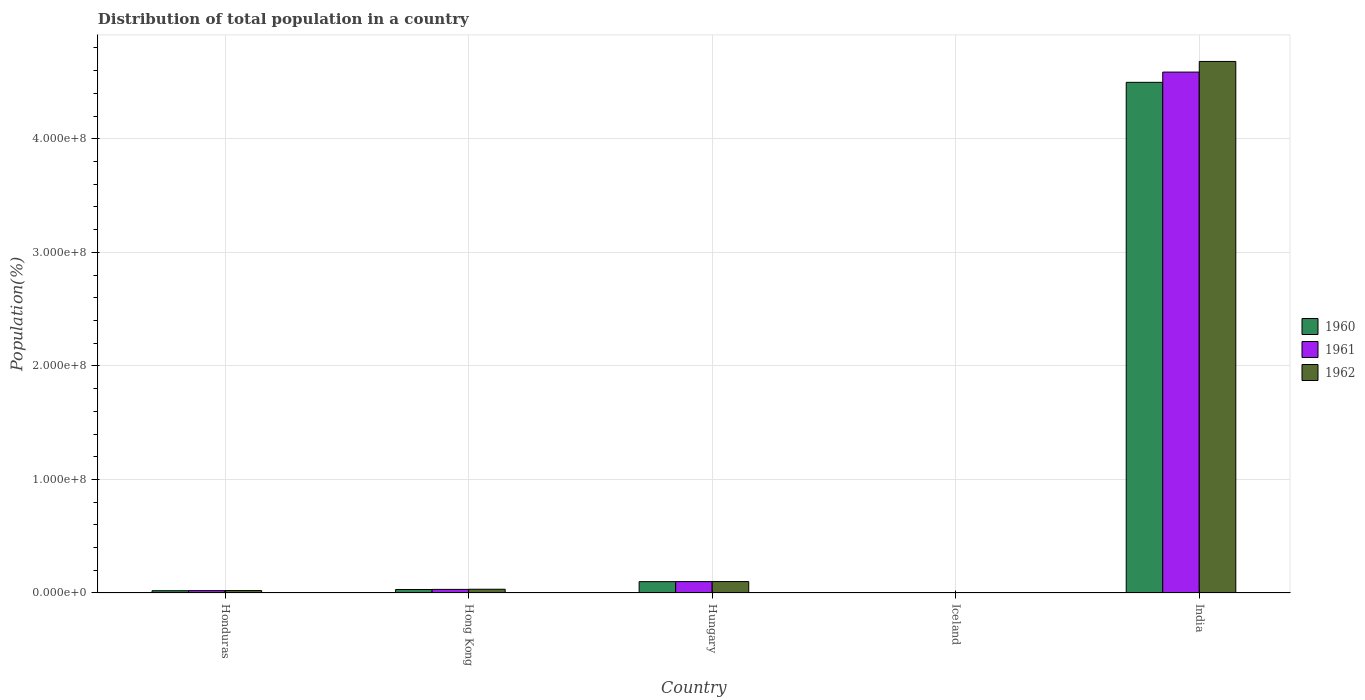How many different coloured bars are there?
Your answer should be very brief. 3. How many groups of bars are there?
Your answer should be very brief. 5. How many bars are there on the 4th tick from the left?
Your response must be concise. 3. How many bars are there on the 5th tick from the right?
Your answer should be compact. 3. What is the label of the 1st group of bars from the left?
Make the answer very short. Honduras. In how many cases, is the number of bars for a given country not equal to the number of legend labels?
Your answer should be compact. 0. What is the population of in 1962 in Honduras?
Your answer should be compact. 2.14e+06. Across all countries, what is the maximum population of in 1961?
Your response must be concise. 4.59e+08. Across all countries, what is the minimum population of in 1960?
Your answer should be very brief. 1.76e+05. In which country was the population of in 1960 maximum?
Give a very brief answer. India. In which country was the population of in 1961 minimum?
Offer a very short reply. Iceland. What is the total population of in 1961 in the graph?
Make the answer very short. 4.74e+08. What is the difference between the population of in 1961 in Hungary and that in India?
Provide a short and direct response. -4.49e+08. What is the difference between the population of in 1962 in Honduras and the population of in 1960 in Hungary?
Your response must be concise. -7.84e+06. What is the average population of in 1960 per country?
Keep it short and to the point. 9.30e+07. What is the difference between the population of of/in 1961 and population of of/in 1960 in Hungary?
Ensure brevity in your answer.  4.54e+04. In how many countries, is the population of in 1961 greater than 220000000 %?
Offer a very short reply. 1. What is the ratio of the population of in 1962 in Hungary to that in India?
Keep it short and to the point. 0.02. What is the difference between the highest and the second highest population of in 1961?
Provide a short and direct response. 4.56e+08. What is the difference between the highest and the lowest population of in 1960?
Offer a very short reply. 4.49e+08. In how many countries, is the population of in 1962 greater than the average population of in 1962 taken over all countries?
Keep it short and to the point. 1. What does the 3rd bar from the right in Hungary represents?
Provide a short and direct response. 1960. How many bars are there?
Keep it short and to the point. 15. Are all the bars in the graph horizontal?
Provide a succinct answer. No. Are the values on the major ticks of Y-axis written in scientific E-notation?
Offer a terse response. Yes. Does the graph contain any zero values?
Your response must be concise. No. Where does the legend appear in the graph?
Your answer should be very brief. Center right. How many legend labels are there?
Ensure brevity in your answer.  3. How are the legend labels stacked?
Provide a succinct answer. Vertical. What is the title of the graph?
Offer a terse response. Distribution of total population in a country. What is the label or title of the Y-axis?
Give a very brief answer. Population(%). What is the Population(%) in 1960 in Honduras?
Your answer should be compact. 2.00e+06. What is the Population(%) in 1961 in Honduras?
Give a very brief answer. 2.07e+06. What is the Population(%) of 1962 in Honduras?
Your answer should be very brief. 2.14e+06. What is the Population(%) in 1960 in Hong Kong?
Offer a very short reply. 3.08e+06. What is the Population(%) of 1961 in Hong Kong?
Your answer should be very brief. 3.17e+06. What is the Population(%) in 1962 in Hong Kong?
Your answer should be very brief. 3.31e+06. What is the Population(%) in 1960 in Hungary?
Offer a very short reply. 9.98e+06. What is the Population(%) in 1961 in Hungary?
Your answer should be compact. 1.00e+07. What is the Population(%) in 1962 in Hungary?
Offer a very short reply. 1.01e+07. What is the Population(%) of 1960 in Iceland?
Give a very brief answer. 1.76e+05. What is the Population(%) in 1961 in Iceland?
Offer a very short reply. 1.79e+05. What is the Population(%) in 1962 in Iceland?
Offer a very short reply. 1.82e+05. What is the Population(%) of 1960 in India?
Keep it short and to the point. 4.50e+08. What is the Population(%) in 1961 in India?
Offer a very short reply. 4.59e+08. What is the Population(%) in 1962 in India?
Offer a very short reply. 4.68e+08. Across all countries, what is the maximum Population(%) in 1960?
Provide a succinct answer. 4.50e+08. Across all countries, what is the maximum Population(%) in 1961?
Keep it short and to the point. 4.59e+08. Across all countries, what is the maximum Population(%) of 1962?
Your answer should be very brief. 4.68e+08. Across all countries, what is the minimum Population(%) of 1960?
Provide a succinct answer. 1.76e+05. Across all countries, what is the minimum Population(%) of 1961?
Ensure brevity in your answer.  1.79e+05. Across all countries, what is the minimum Population(%) of 1962?
Keep it short and to the point. 1.82e+05. What is the total Population(%) of 1960 in the graph?
Make the answer very short. 4.65e+08. What is the total Population(%) in 1961 in the graph?
Offer a terse response. 4.74e+08. What is the total Population(%) in 1962 in the graph?
Your answer should be compact. 4.84e+08. What is the difference between the Population(%) of 1960 in Honduras and that in Hong Kong?
Provide a short and direct response. -1.07e+06. What is the difference between the Population(%) of 1961 in Honduras and that in Hong Kong?
Ensure brevity in your answer.  -1.10e+06. What is the difference between the Population(%) in 1962 in Honduras and that in Hong Kong?
Your answer should be compact. -1.17e+06. What is the difference between the Population(%) of 1960 in Honduras and that in Hungary?
Make the answer very short. -7.98e+06. What is the difference between the Population(%) of 1961 in Honduras and that in Hungary?
Offer a very short reply. -7.96e+06. What is the difference between the Population(%) in 1962 in Honduras and that in Hungary?
Keep it short and to the point. -7.92e+06. What is the difference between the Population(%) in 1960 in Honduras and that in Iceland?
Make the answer very short. 1.83e+06. What is the difference between the Population(%) in 1961 in Honduras and that in Iceland?
Offer a very short reply. 1.89e+06. What is the difference between the Population(%) of 1962 in Honduras and that in Iceland?
Your answer should be compact. 1.96e+06. What is the difference between the Population(%) in 1960 in Honduras and that in India?
Keep it short and to the point. -4.48e+08. What is the difference between the Population(%) in 1961 in Honduras and that in India?
Provide a succinct answer. -4.57e+08. What is the difference between the Population(%) in 1962 in Honduras and that in India?
Give a very brief answer. -4.66e+08. What is the difference between the Population(%) of 1960 in Hong Kong and that in Hungary?
Ensure brevity in your answer.  -6.91e+06. What is the difference between the Population(%) of 1961 in Hong Kong and that in Hungary?
Your answer should be very brief. -6.86e+06. What is the difference between the Population(%) of 1962 in Hong Kong and that in Hungary?
Make the answer very short. -6.76e+06. What is the difference between the Population(%) in 1960 in Hong Kong and that in Iceland?
Offer a very short reply. 2.90e+06. What is the difference between the Population(%) of 1961 in Hong Kong and that in Iceland?
Give a very brief answer. 2.99e+06. What is the difference between the Population(%) of 1962 in Hong Kong and that in Iceland?
Offer a very short reply. 3.12e+06. What is the difference between the Population(%) in 1960 in Hong Kong and that in India?
Make the answer very short. -4.47e+08. What is the difference between the Population(%) of 1961 in Hong Kong and that in India?
Your response must be concise. -4.56e+08. What is the difference between the Population(%) in 1962 in Hong Kong and that in India?
Provide a short and direct response. -4.65e+08. What is the difference between the Population(%) of 1960 in Hungary and that in Iceland?
Offer a terse response. 9.81e+06. What is the difference between the Population(%) of 1961 in Hungary and that in Iceland?
Offer a terse response. 9.85e+06. What is the difference between the Population(%) in 1962 in Hungary and that in Iceland?
Provide a succinct answer. 9.88e+06. What is the difference between the Population(%) of 1960 in Hungary and that in India?
Your response must be concise. -4.40e+08. What is the difference between the Population(%) of 1961 in Hungary and that in India?
Your answer should be very brief. -4.49e+08. What is the difference between the Population(%) in 1962 in Hungary and that in India?
Provide a succinct answer. -4.58e+08. What is the difference between the Population(%) in 1960 in Iceland and that in India?
Provide a succinct answer. -4.49e+08. What is the difference between the Population(%) of 1961 in Iceland and that in India?
Your response must be concise. -4.59e+08. What is the difference between the Population(%) in 1962 in Iceland and that in India?
Keep it short and to the point. -4.68e+08. What is the difference between the Population(%) in 1960 in Honduras and the Population(%) in 1961 in Hong Kong?
Your answer should be compact. -1.17e+06. What is the difference between the Population(%) of 1960 in Honduras and the Population(%) of 1962 in Hong Kong?
Your answer should be very brief. -1.30e+06. What is the difference between the Population(%) in 1961 in Honduras and the Population(%) in 1962 in Hong Kong?
Offer a terse response. -1.24e+06. What is the difference between the Population(%) in 1960 in Honduras and the Population(%) in 1961 in Hungary?
Offer a very short reply. -8.03e+06. What is the difference between the Population(%) of 1960 in Honduras and the Population(%) of 1962 in Hungary?
Give a very brief answer. -8.06e+06. What is the difference between the Population(%) of 1961 in Honduras and the Population(%) of 1962 in Hungary?
Your answer should be compact. -7.99e+06. What is the difference between the Population(%) of 1960 in Honduras and the Population(%) of 1961 in Iceland?
Your answer should be compact. 1.82e+06. What is the difference between the Population(%) in 1960 in Honduras and the Population(%) in 1962 in Iceland?
Provide a succinct answer. 1.82e+06. What is the difference between the Population(%) of 1961 in Honduras and the Population(%) of 1962 in Iceland?
Provide a short and direct response. 1.89e+06. What is the difference between the Population(%) of 1960 in Honduras and the Population(%) of 1961 in India?
Provide a short and direct response. -4.57e+08. What is the difference between the Population(%) in 1960 in Honduras and the Population(%) in 1962 in India?
Your answer should be very brief. -4.66e+08. What is the difference between the Population(%) in 1961 in Honduras and the Population(%) in 1962 in India?
Offer a terse response. -4.66e+08. What is the difference between the Population(%) of 1960 in Hong Kong and the Population(%) of 1961 in Hungary?
Your response must be concise. -6.95e+06. What is the difference between the Population(%) in 1960 in Hong Kong and the Population(%) in 1962 in Hungary?
Your answer should be very brief. -6.99e+06. What is the difference between the Population(%) in 1961 in Hong Kong and the Population(%) in 1962 in Hungary?
Give a very brief answer. -6.89e+06. What is the difference between the Population(%) in 1960 in Hong Kong and the Population(%) in 1961 in Iceland?
Provide a succinct answer. 2.90e+06. What is the difference between the Population(%) of 1960 in Hong Kong and the Population(%) of 1962 in Iceland?
Your response must be concise. 2.89e+06. What is the difference between the Population(%) in 1961 in Hong Kong and the Population(%) in 1962 in Iceland?
Ensure brevity in your answer.  2.99e+06. What is the difference between the Population(%) in 1960 in Hong Kong and the Population(%) in 1961 in India?
Keep it short and to the point. -4.56e+08. What is the difference between the Population(%) in 1960 in Hong Kong and the Population(%) in 1962 in India?
Offer a very short reply. -4.65e+08. What is the difference between the Population(%) of 1961 in Hong Kong and the Population(%) of 1962 in India?
Keep it short and to the point. -4.65e+08. What is the difference between the Population(%) in 1960 in Hungary and the Population(%) in 1961 in Iceland?
Give a very brief answer. 9.80e+06. What is the difference between the Population(%) in 1960 in Hungary and the Population(%) in 1962 in Iceland?
Provide a succinct answer. 9.80e+06. What is the difference between the Population(%) in 1961 in Hungary and the Population(%) in 1962 in Iceland?
Provide a succinct answer. 9.85e+06. What is the difference between the Population(%) of 1960 in Hungary and the Population(%) of 1961 in India?
Offer a terse response. -4.49e+08. What is the difference between the Population(%) of 1960 in Hungary and the Population(%) of 1962 in India?
Offer a very short reply. -4.58e+08. What is the difference between the Population(%) in 1961 in Hungary and the Population(%) in 1962 in India?
Offer a terse response. -4.58e+08. What is the difference between the Population(%) of 1960 in Iceland and the Population(%) of 1961 in India?
Your response must be concise. -4.59e+08. What is the difference between the Population(%) in 1960 in Iceland and the Population(%) in 1962 in India?
Provide a short and direct response. -4.68e+08. What is the difference between the Population(%) of 1961 in Iceland and the Population(%) of 1962 in India?
Your answer should be compact. -4.68e+08. What is the average Population(%) of 1960 per country?
Keep it short and to the point. 9.30e+07. What is the average Population(%) of 1961 per country?
Your response must be concise. 9.48e+07. What is the average Population(%) of 1962 per country?
Offer a terse response. 9.67e+07. What is the difference between the Population(%) of 1960 and Population(%) of 1961 in Honduras?
Your response must be concise. -6.68e+04. What is the difference between the Population(%) of 1960 and Population(%) of 1962 in Honduras?
Offer a terse response. -1.37e+05. What is the difference between the Population(%) in 1961 and Population(%) in 1962 in Honduras?
Provide a succinct answer. -7.01e+04. What is the difference between the Population(%) in 1960 and Population(%) in 1961 in Hong Kong?
Provide a short and direct response. -9.25e+04. What is the difference between the Population(%) of 1960 and Population(%) of 1962 in Hong Kong?
Keep it short and to the point. -2.30e+05. What is the difference between the Population(%) in 1961 and Population(%) in 1962 in Hong Kong?
Make the answer very short. -1.37e+05. What is the difference between the Population(%) of 1960 and Population(%) of 1961 in Hungary?
Your answer should be very brief. -4.54e+04. What is the difference between the Population(%) in 1960 and Population(%) in 1962 in Hungary?
Offer a very short reply. -7.78e+04. What is the difference between the Population(%) of 1961 and Population(%) of 1962 in Hungary?
Provide a short and direct response. -3.24e+04. What is the difference between the Population(%) in 1960 and Population(%) in 1961 in Iceland?
Offer a very short reply. -3455. What is the difference between the Population(%) in 1960 and Population(%) in 1962 in Iceland?
Your answer should be very brief. -6804. What is the difference between the Population(%) of 1961 and Population(%) of 1962 in Iceland?
Give a very brief answer. -3349. What is the difference between the Population(%) of 1960 and Population(%) of 1961 in India?
Make the answer very short. -9.03e+06. What is the difference between the Population(%) in 1960 and Population(%) in 1962 in India?
Provide a succinct answer. -1.84e+07. What is the difference between the Population(%) in 1961 and Population(%) in 1962 in India?
Ensure brevity in your answer.  -9.36e+06. What is the ratio of the Population(%) of 1960 in Honduras to that in Hong Kong?
Your answer should be compact. 0.65. What is the ratio of the Population(%) of 1961 in Honduras to that in Hong Kong?
Give a very brief answer. 0.65. What is the ratio of the Population(%) of 1962 in Honduras to that in Hong Kong?
Provide a succinct answer. 0.65. What is the ratio of the Population(%) of 1960 in Honduras to that in Hungary?
Ensure brevity in your answer.  0.2. What is the ratio of the Population(%) in 1961 in Honduras to that in Hungary?
Provide a short and direct response. 0.21. What is the ratio of the Population(%) in 1962 in Honduras to that in Hungary?
Provide a short and direct response. 0.21. What is the ratio of the Population(%) of 1960 in Honduras to that in Iceland?
Make the answer very short. 11.4. What is the ratio of the Population(%) of 1961 in Honduras to that in Iceland?
Your answer should be very brief. 11.56. What is the ratio of the Population(%) of 1962 in Honduras to that in Iceland?
Give a very brief answer. 11.73. What is the ratio of the Population(%) in 1960 in Honduras to that in India?
Make the answer very short. 0. What is the ratio of the Population(%) of 1961 in Honduras to that in India?
Provide a succinct answer. 0. What is the ratio of the Population(%) of 1962 in Honduras to that in India?
Provide a succinct answer. 0. What is the ratio of the Population(%) in 1960 in Hong Kong to that in Hungary?
Offer a terse response. 0.31. What is the ratio of the Population(%) of 1961 in Hong Kong to that in Hungary?
Your answer should be very brief. 0.32. What is the ratio of the Population(%) in 1962 in Hong Kong to that in Hungary?
Provide a succinct answer. 0.33. What is the ratio of the Population(%) of 1960 in Hong Kong to that in Iceland?
Your response must be concise. 17.52. What is the ratio of the Population(%) of 1961 in Hong Kong to that in Iceland?
Provide a short and direct response. 17.7. What is the ratio of the Population(%) in 1962 in Hong Kong to that in Iceland?
Ensure brevity in your answer.  18.12. What is the ratio of the Population(%) of 1960 in Hong Kong to that in India?
Your response must be concise. 0.01. What is the ratio of the Population(%) of 1961 in Hong Kong to that in India?
Your response must be concise. 0.01. What is the ratio of the Population(%) of 1962 in Hong Kong to that in India?
Your response must be concise. 0.01. What is the ratio of the Population(%) in 1960 in Hungary to that in Iceland?
Give a very brief answer. 56.86. What is the ratio of the Population(%) of 1961 in Hungary to that in Iceland?
Keep it short and to the point. 56.02. What is the ratio of the Population(%) of 1962 in Hungary to that in Iceland?
Make the answer very short. 55.17. What is the ratio of the Population(%) in 1960 in Hungary to that in India?
Your response must be concise. 0.02. What is the ratio of the Population(%) of 1961 in Hungary to that in India?
Your answer should be compact. 0.02. What is the ratio of the Population(%) in 1962 in Hungary to that in India?
Ensure brevity in your answer.  0.02. What is the ratio of the Population(%) of 1960 in Iceland to that in India?
Your response must be concise. 0. What is the ratio of the Population(%) in 1961 in Iceland to that in India?
Provide a short and direct response. 0. What is the difference between the highest and the second highest Population(%) of 1960?
Your answer should be compact. 4.40e+08. What is the difference between the highest and the second highest Population(%) in 1961?
Offer a very short reply. 4.49e+08. What is the difference between the highest and the second highest Population(%) in 1962?
Your answer should be compact. 4.58e+08. What is the difference between the highest and the lowest Population(%) in 1960?
Your response must be concise. 4.49e+08. What is the difference between the highest and the lowest Population(%) in 1961?
Provide a succinct answer. 4.59e+08. What is the difference between the highest and the lowest Population(%) of 1962?
Offer a very short reply. 4.68e+08. 